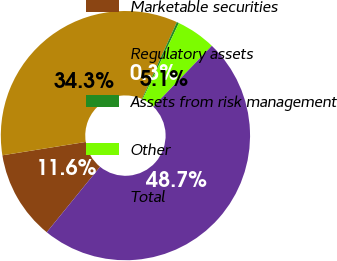Convert chart to OTSL. <chart><loc_0><loc_0><loc_500><loc_500><pie_chart><fcel>Marketable securities<fcel>Regulatory assets<fcel>Assets from risk management<fcel>Other<fcel>Total<nl><fcel>11.6%<fcel>34.3%<fcel>0.29%<fcel>5.13%<fcel>48.68%<nl></chart> 